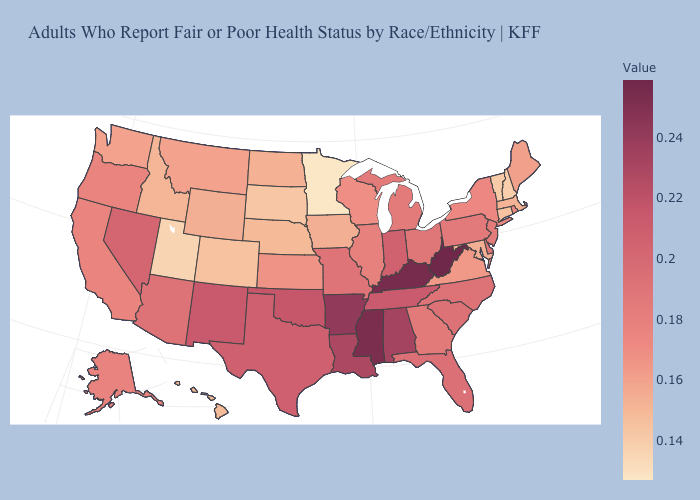Among the states that border Washington , which have the highest value?
Keep it brief. Oregon. Does Utah have the lowest value in the West?
Write a very short answer. Yes. Which states have the highest value in the USA?
Write a very short answer. West Virginia. Which states have the highest value in the USA?
Concise answer only. West Virginia. 